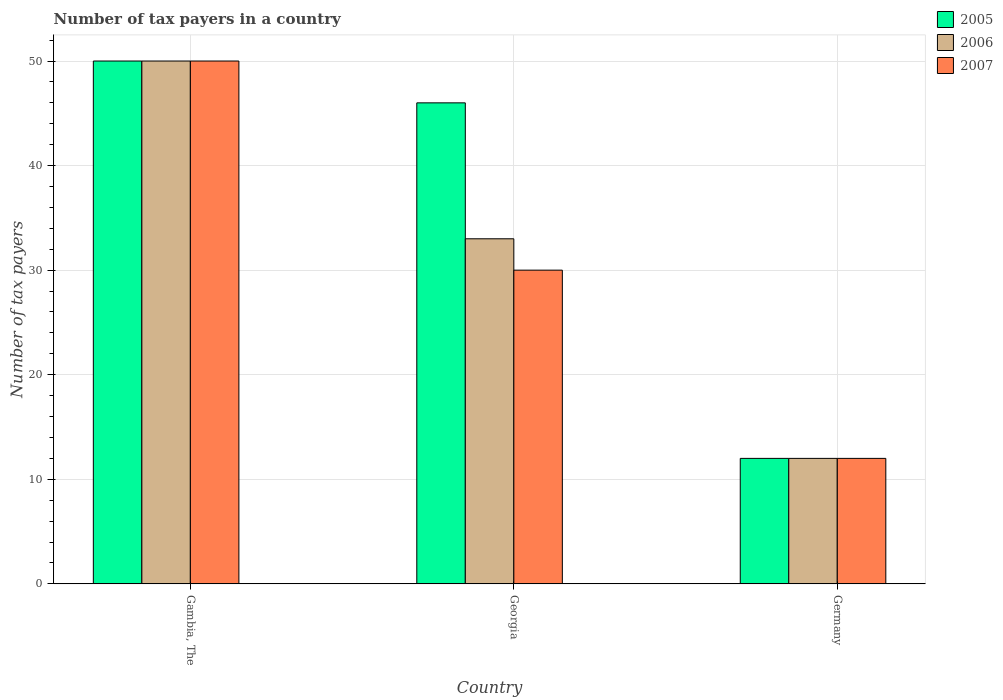How many different coloured bars are there?
Your response must be concise. 3. Are the number of bars per tick equal to the number of legend labels?
Offer a very short reply. Yes. Are the number of bars on each tick of the X-axis equal?
Give a very brief answer. Yes. How many bars are there on the 2nd tick from the left?
Ensure brevity in your answer.  3. How many bars are there on the 1st tick from the right?
Provide a succinct answer. 3. What is the label of the 2nd group of bars from the left?
Provide a succinct answer. Georgia. Across all countries, what is the minimum number of tax payers in in 2006?
Make the answer very short. 12. In which country was the number of tax payers in in 2005 maximum?
Make the answer very short. Gambia, The. In which country was the number of tax payers in in 2007 minimum?
Your answer should be compact. Germany. What is the total number of tax payers in in 2007 in the graph?
Offer a very short reply. 92. What is the difference between the number of tax payers in in 2005 in Germany and the number of tax payers in in 2007 in Gambia, The?
Give a very brief answer. -38. What is the average number of tax payers in in 2007 per country?
Your response must be concise. 30.67. In how many countries, is the number of tax payers in in 2007 greater than 20?
Make the answer very short. 2. Is the number of tax payers in in 2007 in Gambia, The less than that in Georgia?
Provide a succinct answer. No. Is the difference between the number of tax payers in in 2006 in Georgia and Germany greater than the difference between the number of tax payers in in 2005 in Georgia and Germany?
Make the answer very short. No. What is the difference between the highest and the second highest number of tax payers in in 2005?
Make the answer very short. 38. What is the difference between the highest and the lowest number of tax payers in in 2007?
Ensure brevity in your answer.  38. In how many countries, is the number of tax payers in in 2007 greater than the average number of tax payers in in 2007 taken over all countries?
Offer a terse response. 1. What does the 1st bar from the left in Georgia represents?
Offer a terse response. 2005. Is it the case that in every country, the sum of the number of tax payers in in 2007 and number of tax payers in in 2006 is greater than the number of tax payers in in 2005?
Offer a terse response. Yes. How many countries are there in the graph?
Keep it short and to the point. 3. Does the graph contain grids?
Your response must be concise. Yes. How are the legend labels stacked?
Your answer should be very brief. Vertical. What is the title of the graph?
Your response must be concise. Number of tax payers in a country. Does "1975" appear as one of the legend labels in the graph?
Offer a terse response. No. What is the label or title of the X-axis?
Your response must be concise. Country. What is the label or title of the Y-axis?
Provide a succinct answer. Number of tax payers. What is the Number of tax payers in 2005 in Gambia, The?
Make the answer very short. 50. What is the Number of tax payers in 2005 in Georgia?
Make the answer very short. 46. What is the Number of tax payers of 2006 in Germany?
Ensure brevity in your answer.  12. Across all countries, what is the maximum Number of tax payers in 2005?
Give a very brief answer. 50. Across all countries, what is the maximum Number of tax payers in 2006?
Offer a terse response. 50. Across all countries, what is the maximum Number of tax payers of 2007?
Give a very brief answer. 50. Across all countries, what is the minimum Number of tax payers in 2006?
Offer a terse response. 12. Across all countries, what is the minimum Number of tax payers of 2007?
Offer a very short reply. 12. What is the total Number of tax payers in 2005 in the graph?
Offer a very short reply. 108. What is the total Number of tax payers in 2007 in the graph?
Your response must be concise. 92. What is the difference between the Number of tax payers in 2007 in Gambia, The and that in Georgia?
Offer a very short reply. 20. What is the difference between the Number of tax payers of 2006 in Gambia, The and that in Germany?
Offer a terse response. 38. What is the difference between the Number of tax payers of 2007 in Gambia, The and that in Germany?
Offer a very short reply. 38. What is the difference between the Number of tax payers of 2006 in Georgia and that in Germany?
Provide a short and direct response. 21. What is the difference between the Number of tax payers in 2005 in Gambia, The and the Number of tax payers in 2007 in Germany?
Provide a succinct answer. 38. What is the difference between the Number of tax payers in 2005 in Georgia and the Number of tax payers in 2006 in Germany?
Ensure brevity in your answer.  34. What is the difference between the Number of tax payers in 2006 in Georgia and the Number of tax payers in 2007 in Germany?
Give a very brief answer. 21. What is the average Number of tax payers in 2006 per country?
Provide a short and direct response. 31.67. What is the average Number of tax payers in 2007 per country?
Keep it short and to the point. 30.67. What is the difference between the Number of tax payers in 2005 and Number of tax payers in 2007 in Gambia, The?
Your answer should be compact. 0. What is the difference between the Number of tax payers of 2006 and Number of tax payers of 2007 in Gambia, The?
Give a very brief answer. 0. What is the difference between the Number of tax payers of 2005 and Number of tax payers of 2006 in Georgia?
Make the answer very short. 13. What is the difference between the Number of tax payers in 2005 and Number of tax payers in 2006 in Germany?
Provide a succinct answer. 0. What is the difference between the Number of tax payers of 2005 and Number of tax payers of 2007 in Germany?
Make the answer very short. 0. What is the difference between the Number of tax payers of 2006 and Number of tax payers of 2007 in Germany?
Make the answer very short. 0. What is the ratio of the Number of tax payers of 2005 in Gambia, The to that in Georgia?
Provide a succinct answer. 1.09. What is the ratio of the Number of tax payers of 2006 in Gambia, The to that in Georgia?
Make the answer very short. 1.52. What is the ratio of the Number of tax payers in 2005 in Gambia, The to that in Germany?
Your answer should be compact. 4.17. What is the ratio of the Number of tax payers in 2006 in Gambia, The to that in Germany?
Make the answer very short. 4.17. What is the ratio of the Number of tax payers of 2007 in Gambia, The to that in Germany?
Your answer should be compact. 4.17. What is the ratio of the Number of tax payers in 2005 in Georgia to that in Germany?
Provide a short and direct response. 3.83. What is the ratio of the Number of tax payers of 2006 in Georgia to that in Germany?
Your answer should be very brief. 2.75. What is the difference between the highest and the second highest Number of tax payers in 2005?
Make the answer very short. 4. What is the difference between the highest and the second highest Number of tax payers of 2006?
Keep it short and to the point. 17. What is the difference between the highest and the second highest Number of tax payers in 2007?
Give a very brief answer. 20. What is the difference between the highest and the lowest Number of tax payers in 2006?
Your response must be concise. 38. 